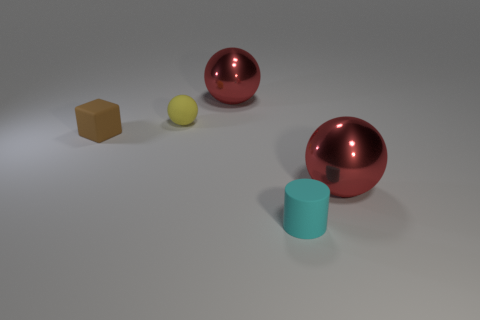Subtract all red balls. How many balls are left? 1 Subtract 1 balls. How many balls are left? 2 Add 5 big red shiny spheres. How many big red shiny spheres exist? 7 Add 5 red objects. How many objects exist? 10 Subtract all yellow balls. How many balls are left? 2 Subtract 0 blue cubes. How many objects are left? 5 Subtract all balls. How many objects are left? 2 Subtract all red spheres. Subtract all purple cylinders. How many spheres are left? 1 Subtract all yellow cylinders. How many red balls are left? 2 Subtract all big gray blocks. Subtract all brown blocks. How many objects are left? 4 